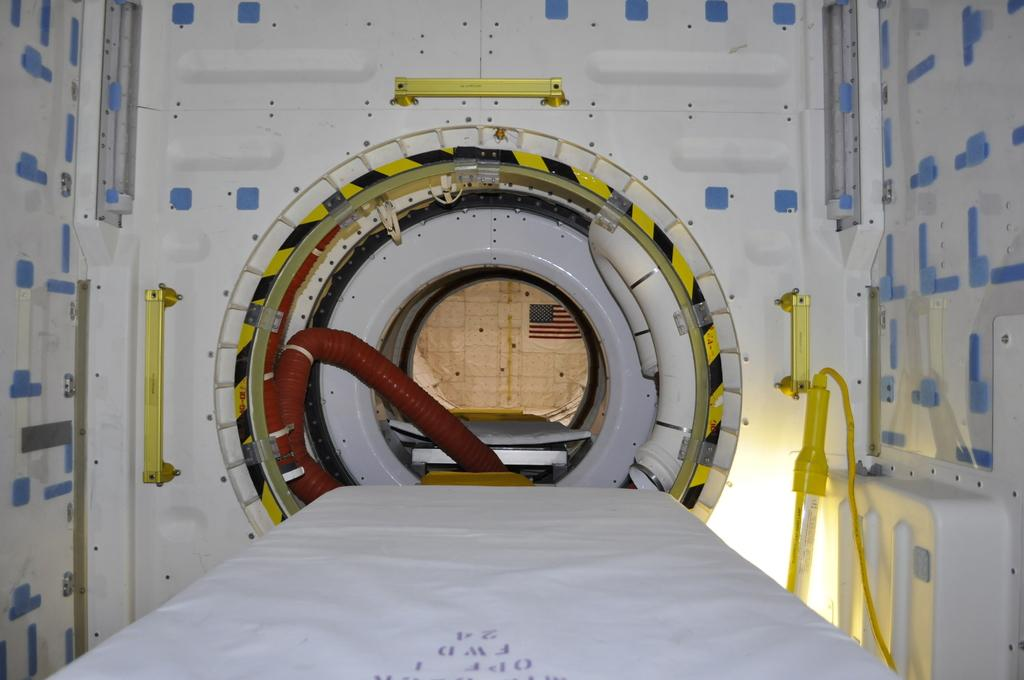What is located in the foreground of the image? There is a bed in the foreground of the image. What else can be seen in the foreground besides the bed? There are pipes visible in the foreground. What is in the background of the image? There is a flag and a wall in the background of the image. What is attached to the wall in the background? There are rods on the wall in the background. What type of goldfish can be seen swimming in the bed in the image? There are no goldfish present in the image; it features a bed and pipes in the foreground, and a flag and wall with rods in the background. 